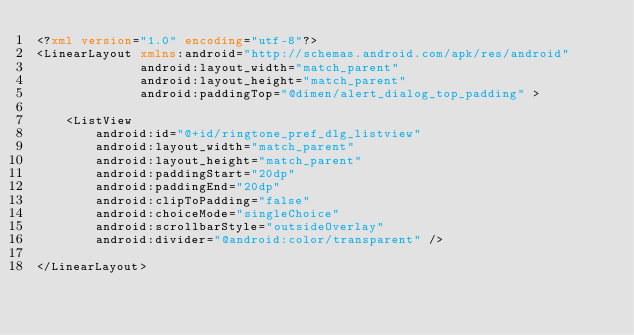Convert code to text. <code><loc_0><loc_0><loc_500><loc_500><_XML_><?xml version="1.0" encoding="utf-8"?>
<LinearLayout xmlns:android="http://schemas.android.com/apk/res/android"
              android:layout_width="match_parent"
              android:layout_height="match_parent"
              android:paddingTop="@dimen/alert_dialog_top_padding" >

    <ListView
        android:id="@+id/ringtone_pref_dlg_listview"
        android:layout_width="match_parent"
        android:layout_height="match_parent"
        android:paddingStart="20dp"
        android:paddingEnd="20dp"
        android:clipToPadding="false"
        android:choiceMode="singleChoice"
        android:scrollbarStyle="outsideOverlay"
        android:divider="@android:color/transparent" />

</LinearLayout>
</code> 